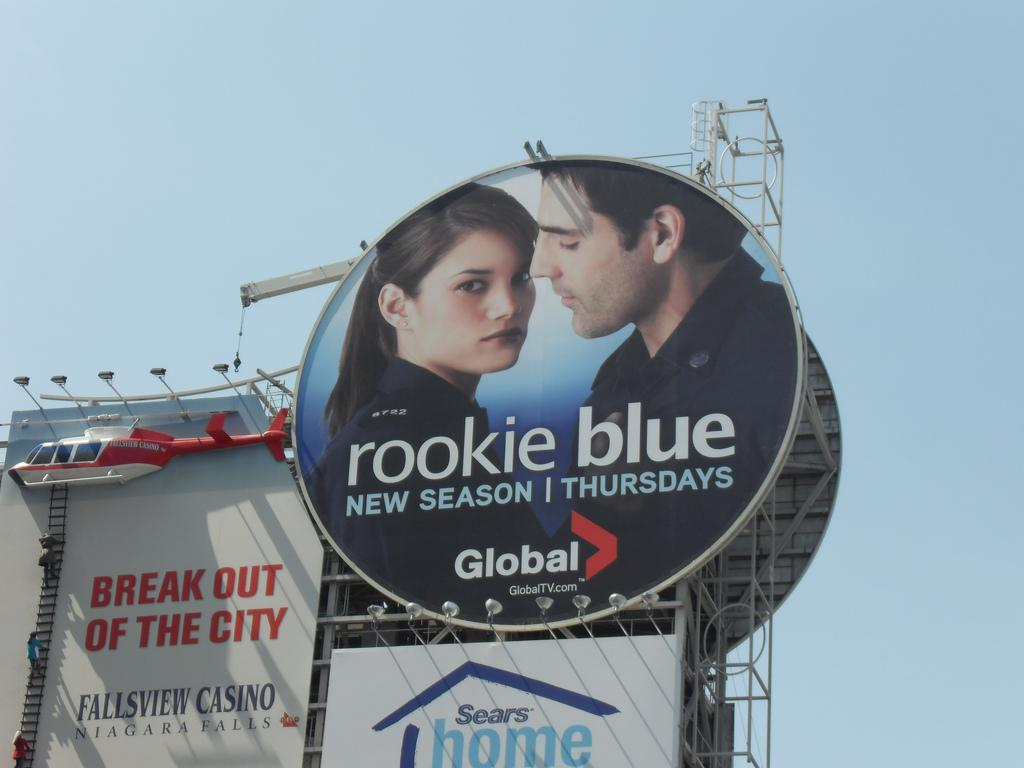What is the main structure visible in the image? There is a building in the image. Are there any additional features or elements related to the building? Yes, there are advancement boards associated with the building. What type of stew is being served at the meeting in the image? There is no meeting or stew present in the image; it only features a building and advancement boards. 